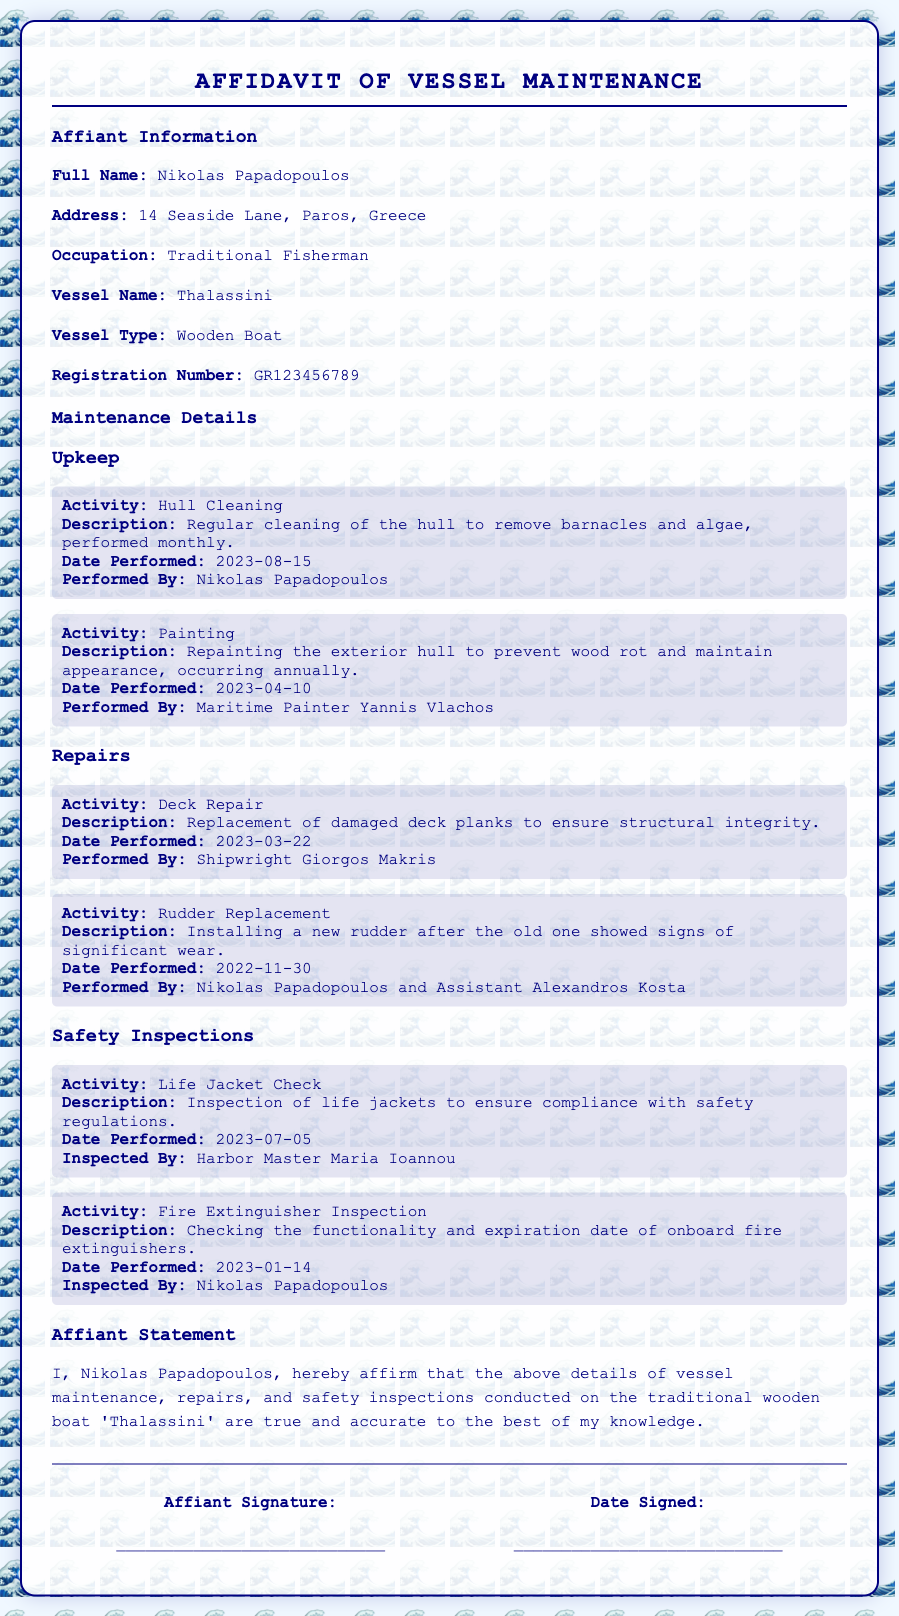What is the full name of the affiant? The full name of the affiant is stated in the document as Nikolas Papadopoulos.
Answer: Nikolas Papadopoulos What is the vessel name? The vessel's name is explicitly mentioned in the document as 'Thalassini'.
Answer: Thalassini What type of vessel is it? The document categorizes the vessel as a Wooden Boat.
Answer: Wooden Boat When was the last hull cleaning performed? The date of the last hull cleaning activity is provided in the document as 2023-08-15.
Answer: 2023-08-15 Who performed the painting of the vessel? The document identifies Maritime Painter Yannis Vlachos as the person who performed the painting.
Answer: Yannis Vlachos What was the date of the last fire extinguisher inspection? The date for the last fire extinguisher inspection listed in the document is 2023-01-14.
Answer: 2023-01-14 Who inspected the life jackets? The inspection of life jackets was conducted by Harbor Master Maria Ioannou as noted in the document.
Answer: Maria Ioannou What activity involved the replacement of deck planks? The document specifies the activity of Deck Repair for the replacement of damaged deck planks.
Answer: Deck Repair What is included in the affiant's statement? The affiant's statement includes an affirmation that the vessel maintenance details are true and accurate.
Answer: True and accurate 